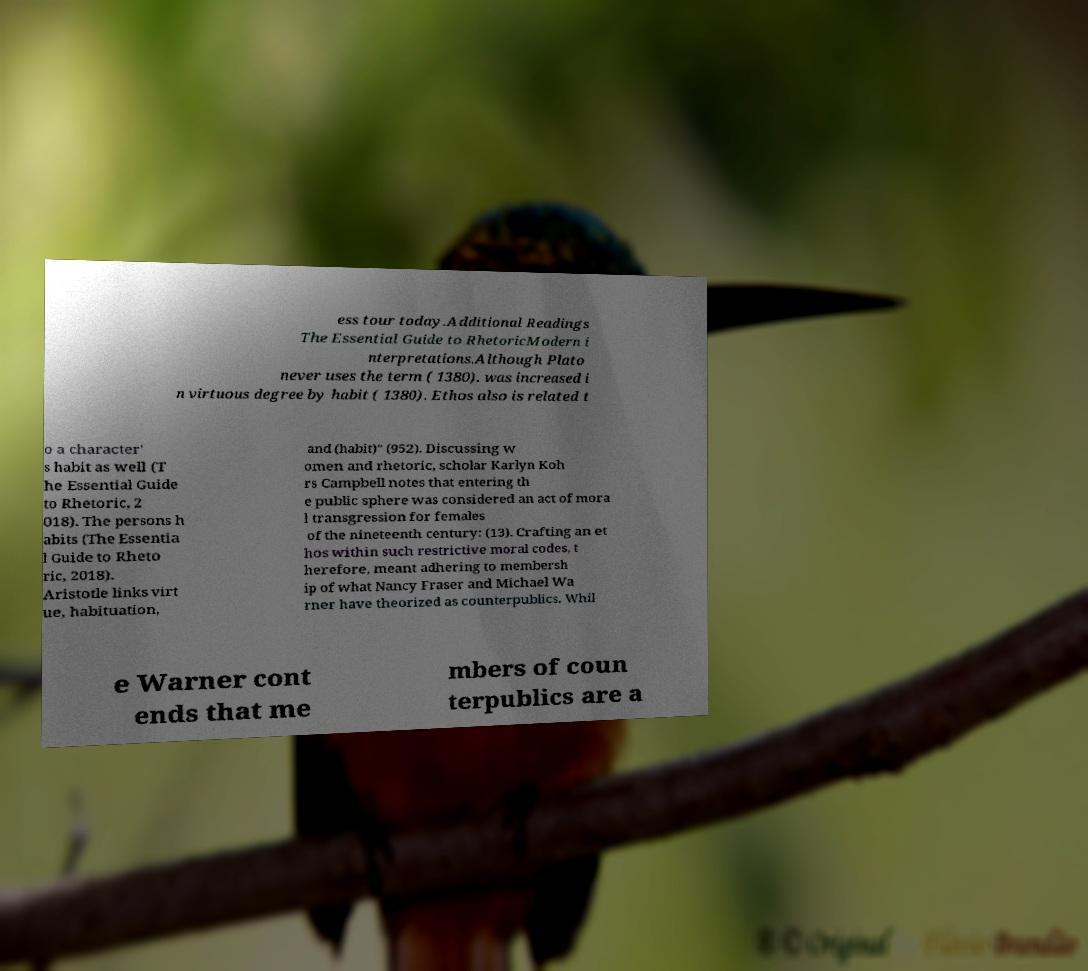Please read and relay the text visible in this image. What does it say? ess tour today.Additional Readings The Essential Guide to RhetoricModern i nterpretations.Although Plato never uses the term ( 1380). was increased i n virtuous degree by habit ( 1380). Ethos also is related t o a character' s habit as well (T he Essential Guide to Rhetoric, 2 018). The persons h abits (The Essentia l Guide to Rheto ric, 2018). Aristotle links virt ue, habituation, and (habit)" (952). Discussing w omen and rhetoric, scholar Karlyn Koh rs Campbell notes that entering th e public sphere was considered an act of mora l transgression for females of the nineteenth century: (13). Crafting an et hos within such restrictive moral codes, t herefore, meant adhering to membersh ip of what Nancy Fraser and Michael Wa rner have theorized as counterpublics. Whil e Warner cont ends that me mbers of coun terpublics are a 